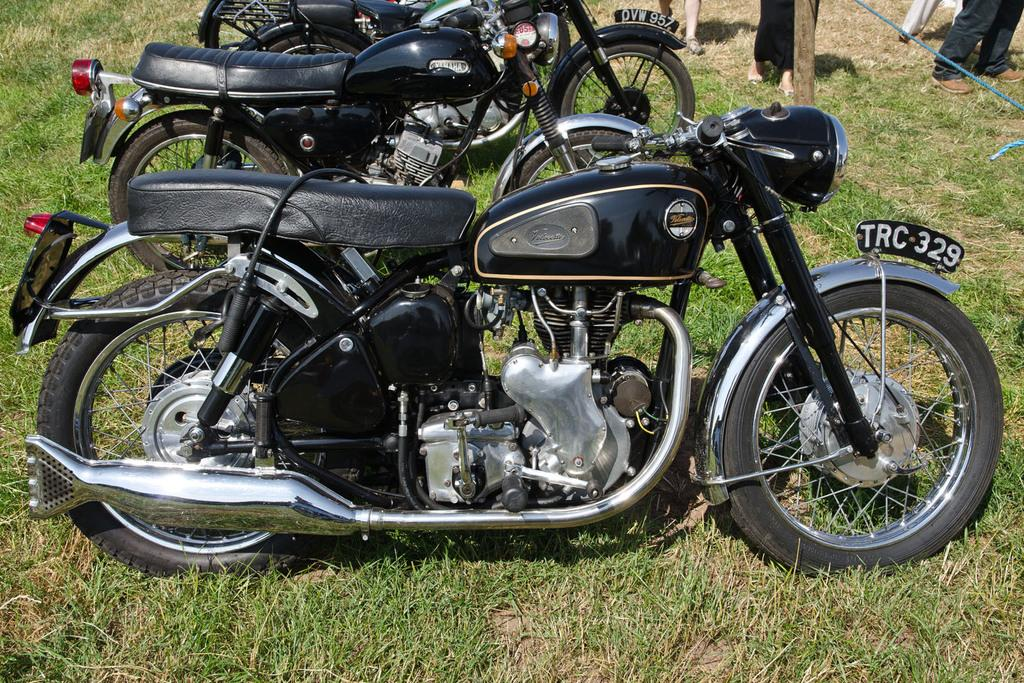What type of vehicles are in the image? There are three black bikes in the image. What is the surface beneath the bikes? The bikes are on a greenery ground. Are there any people visible in the image? Yes, there are people standing in the right top corner of the image. What type of sink can be seen in the image? There is no sink present in the image. Is the ground covered in snow in the image? No, the ground is not covered in snow; it is a greenery ground. 